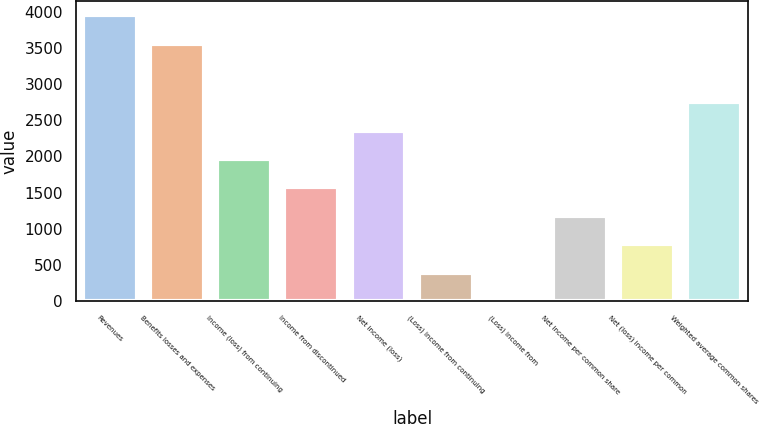Convert chart to OTSL. <chart><loc_0><loc_0><loc_500><loc_500><bar_chart><fcel>Revenues<fcel>Benefits losses and expenses<fcel>Income (loss) from continuing<fcel>Income from discontinued<fcel>Net income (loss)<fcel>(Loss) income from continuing<fcel>(Loss) income from<fcel>Net income per common share<fcel>Net (loss) income per common<fcel>Weighted average common shares<nl><fcel>3948.99<fcel>3556<fcel>1965.01<fcel>1572.02<fcel>2358<fcel>393.05<fcel>0.06<fcel>1179.03<fcel>786.04<fcel>2750.99<nl></chart> 